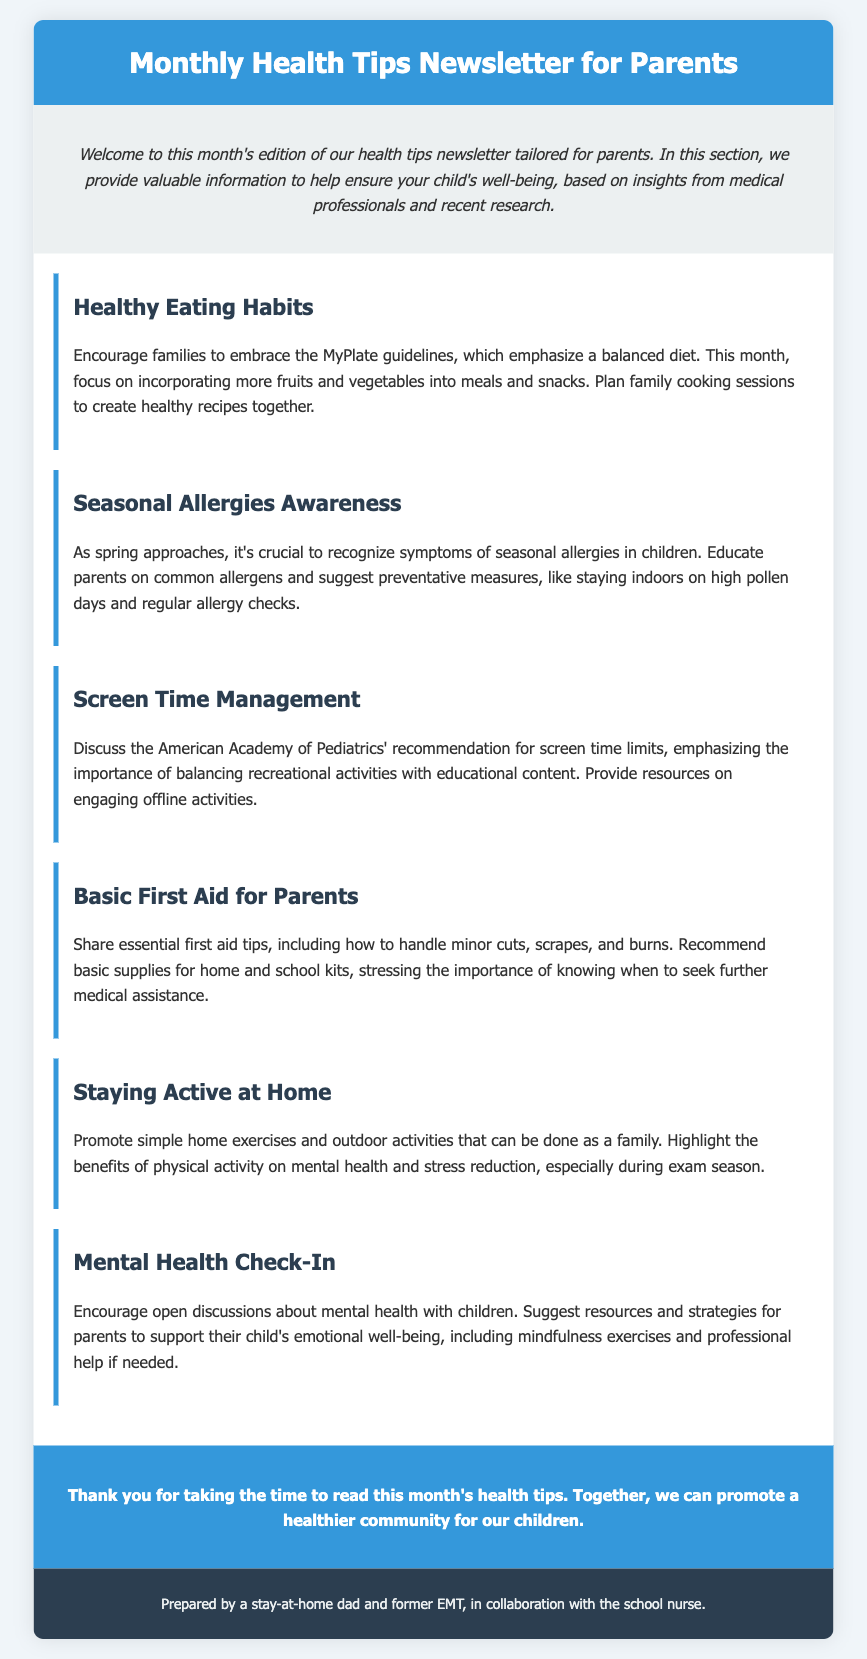What is the title of the newsletter? The title explicitly stated in the document serves as the name of this communication, which aims to provide health tips for parents.
Answer: Monthly Health Tips Newsletter for Parents What is one focus topic of this month's edition? The document includes a summary of various health-related topics aimed at parents, indicating multiple areas of focus.
Answer: Healthy Eating Habits How can families improve their eating habits? The newsletter suggests specific guidelines for healthy eating, emphasizing actions families can take to encourage better food choices together.
Answer: Incorporating more fruits and vegetables What should parents recognize as symptoms? The document focuses on the awareness of specific health conditions in children, prompting parents to identify certain common allergic reactions.
Answer: Symptoms of seasonal allergies What is the recommended activity related to screen time? The document highlights an organization's guidance on media use for children, suggesting how families should balance online and offline activities.
Answer: Balancing recreational activities with educational content What is one method for parents to support mental health? The newsletter suggests various strategies for parents to help their children with emotional well-being, including certain activities and professional resources.
Answer: Mindfulness exercises What purpose does the first aid section serve? This portion of the newsletter is designed to impart critical information on managing injuries, underscoring its importance in everyday situations for parents.
Answer: Essential first aid tips How does physical activity benefit children? The document elaborates on the positive impacts of exercise, particularly emphasizing mental health and coping mechanisms during stressful times.
Answer: Mental health and stress reduction What is the primary goal of the newsletter? The overarching aim of this monthly communication is articulated in the closing remarks, focusing on community health and collective effort.
Answer: Promote a healthier community for our children 